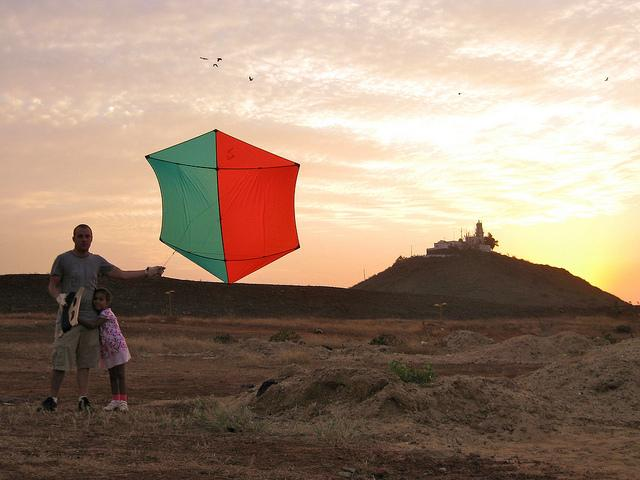What is on the item in the man's right hand? kite 